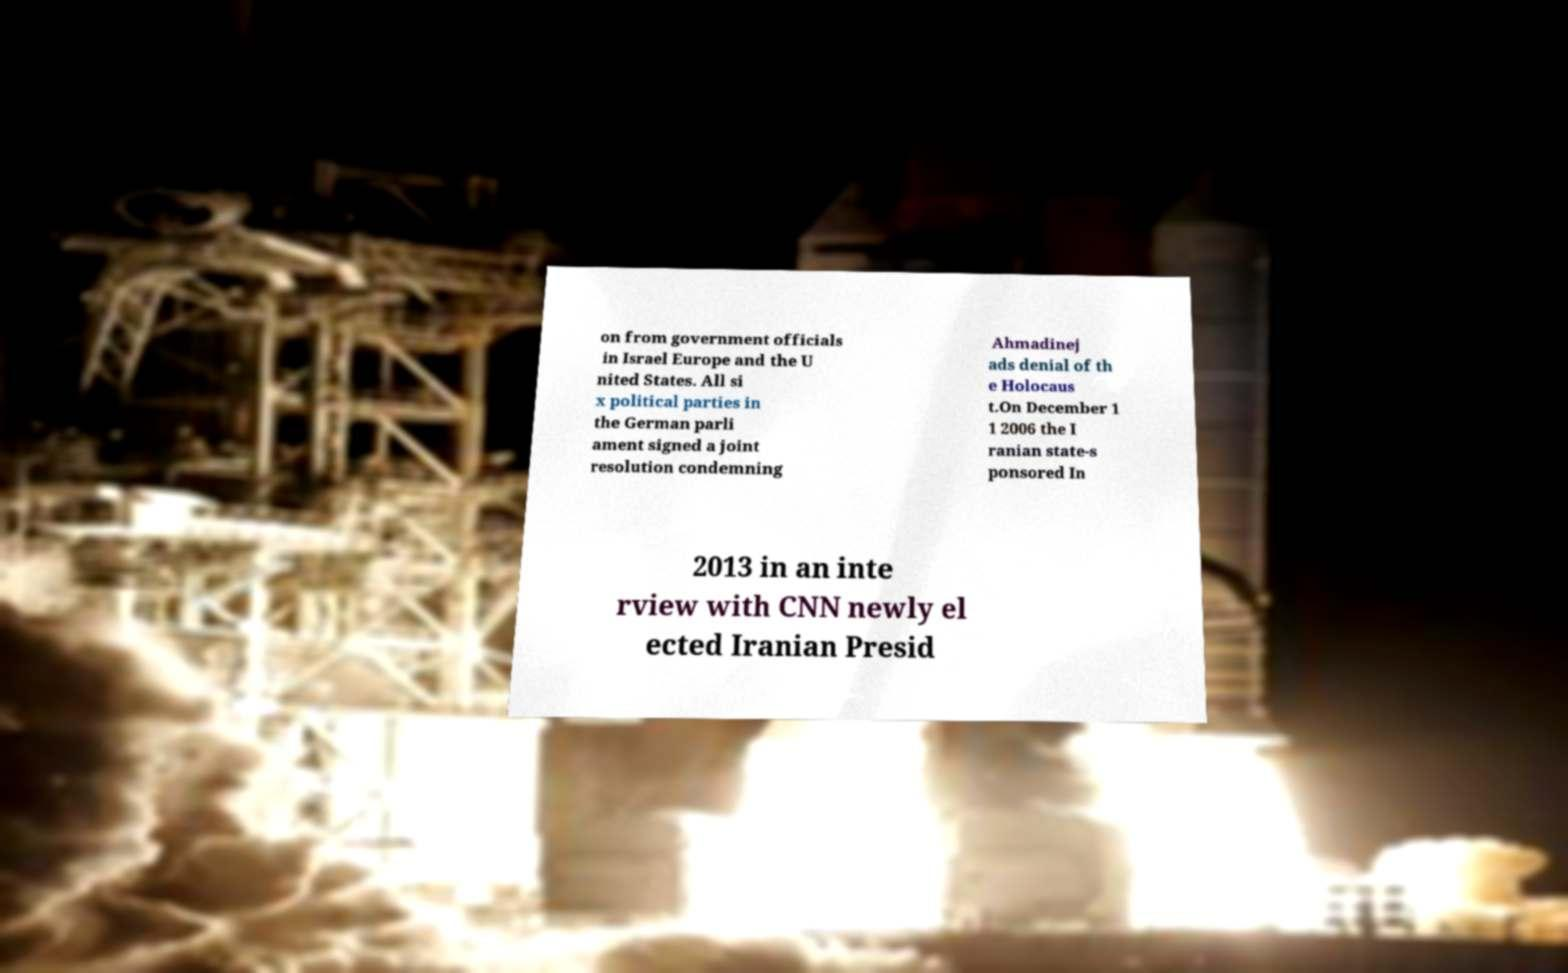What messages or text are displayed in this image? I need them in a readable, typed format. on from government officials in Israel Europe and the U nited States. All si x political parties in the German parli ament signed a joint resolution condemning Ahmadinej ads denial of th e Holocaus t.On December 1 1 2006 the I ranian state-s ponsored In 2013 in an inte rview with CNN newly el ected Iranian Presid 